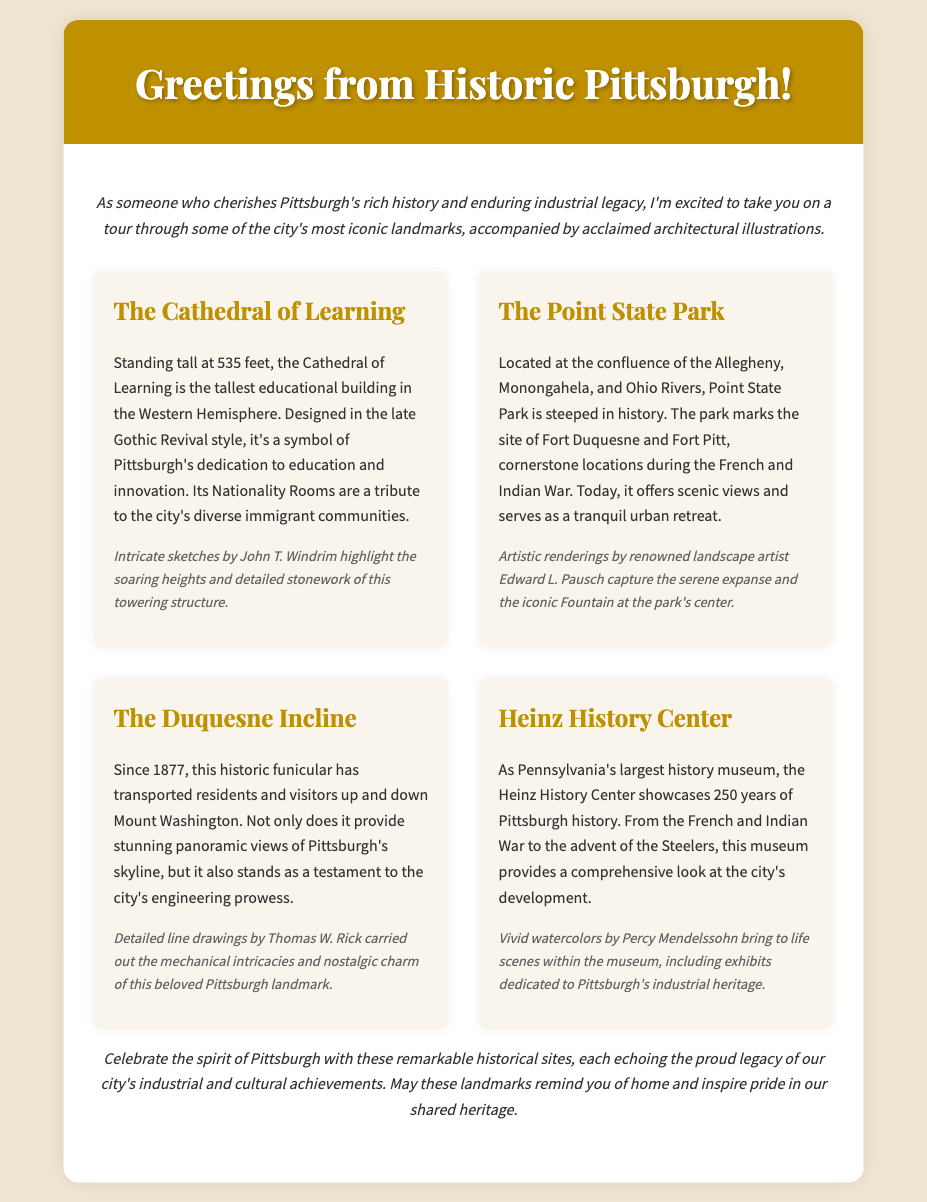What is the tallest educational building in the Western Hemisphere? The document identifies the Cathedral of Learning as the tallest educational building in the Western Hemisphere.
Answer: Cathedral of Learning Who created the illustrations for the Cathedral of Learning? The architectural illustrations for the Cathedral of Learning were created by John T. Windrim.
Answer: John T. Windrim What park is located at the confluence of the Allegheny, Monongahela, and Ohio Rivers? The document mentions Point State Park as the park located at this confluence.
Answer: Point State Park In what year did the Duquesne Incline start operating? According to the document, the Duquesne Incline has been in operation since 1877.
Answer: 1877 Which museum showcases 250 years of Pittsburgh history? The Heinz History Center is noted as the museum showcasing this history in the document.
Answer: Heinz History Center What architectural style is the Cathedral of Learning designed in? The document states that the Cathedral of Learning is designed in the late Gothic Revival style.
Answer: Late Gothic Revival What is the main function of Point State Park today? The document describes Point State Park as serving as a tranquil urban retreat.
Answer: Urban retreat Which artist captured the serene expanse of Point State Park? Edward L. Pausch is credited with capturing the scenery of Point State Park through artistic renderings.
Answer: Edward L. Pausch What is the significance of the Duquesne Incline in terms of engineering? The document highlights the Duquesne Incline as a testament to the city's engineering prowess.
Answer: Engineering prowess 